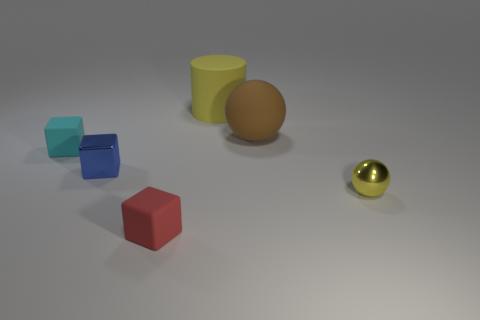What is the color of the matte cube that is in front of the tiny metal thing that is to the left of the tiny red cube?
Give a very brief answer. Red. What number of other things are there of the same material as the tiny red cube
Provide a short and direct response. 3. How many small red objects are to the right of the tiny matte thing that is in front of the small yellow ball?
Your answer should be compact. 0. Is there anything else that has the same shape as the large yellow object?
Offer a very short reply. No. There is a rubber block that is on the right side of the cyan rubber cube; is it the same color as the small shiny object on the left side of the yellow metallic sphere?
Your answer should be very brief. No. Are there fewer large green cylinders than small yellow shiny spheres?
Provide a short and direct response. Yes. What shape is the yellow object in front of the yellow thing that is behind the tiny yellow metal thing?
Your answer should be very brief. Sphere. Are there any other things that are the same size as the brown rubber thing?
Provide a succinct answer. Yes. What shape is the small metal object that is to the left of the large matte thing behind the ball that is behind the tiny cyan rubber object?
Your response must be concise. Cube. What number of things are small objects on the left side of the big cylinder or things behind the red rubber block?
Offer a very short reply. 6. 